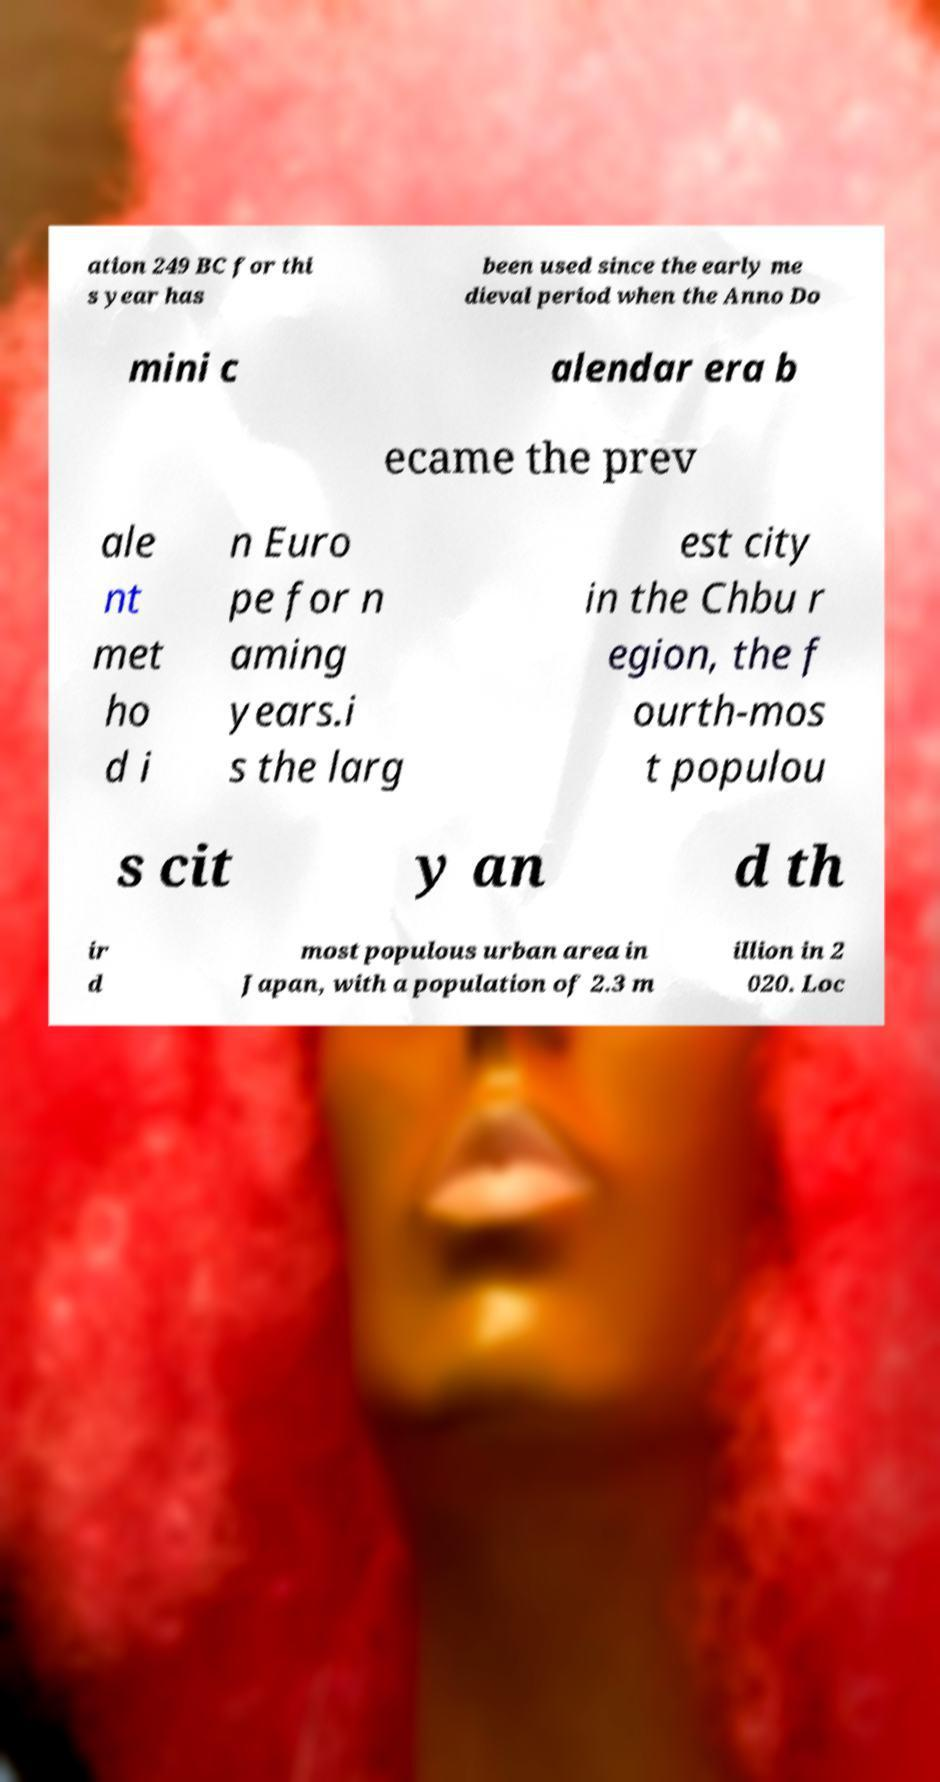I need the written content from this picture converted into text. Can you do that? ation 249 BC for thi s year has been used since the early me dieval period when the Anno Do mini c alendar era b ecame the prev ale nt met ho d i n Euro pe for n aming years.i s the larg est city in the Chbu r egion, the f ourth-mos t populou s cit y an d th ir d most populous urban area in Japan, with a population of 2.3 m illion in 2 020. Loc 